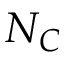<formula> <loc_0><loc_0><loc_500><loc_500>N _ { C }</formula> 